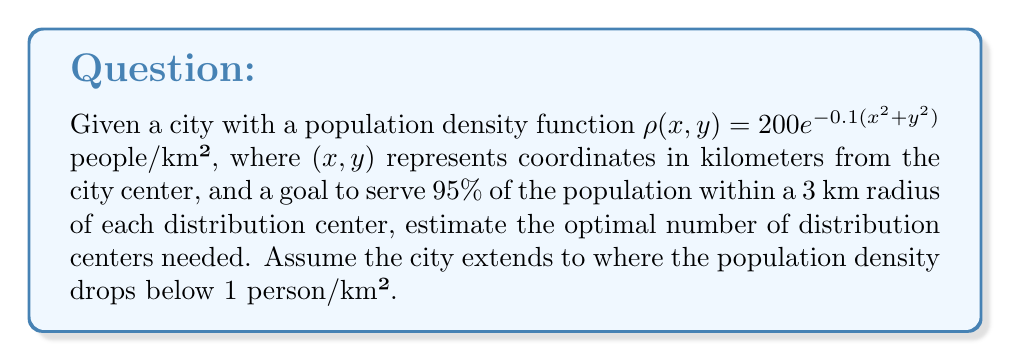Teach me how to tackle this problem. 1. Find the city's boundary:
   Set $\rho(x,y) = 1$ and solve for $r$:
   $$1 = 200e^{-0.1(x^2+y^2)}$$
   $$e^{-0.1(x^2+y^2)} = \frac{1}{200}$$
   $$-0.1(x^2+y^2) = \ln(\frac{1}{200})$$
   $$x^2+y^2 = -10\ln(\frac{1}{200}) \approx 52.6$$
   $$r = \sqrt{52.6} \approx 7.25 \text{ km}$$

2. Calculate the total population:
   $$P = \int_0^{2\pi}\int_0^{7.25} 200e^{-0.1r^2}r\,dr\,d\theta$$
   $$P = 2\pi\int_0^{7.25} 200re^{-0.1r^2}\,dr$$
   $$P = 2\pi[-1000e^{-0.1r^2}]_0^{7.25}$$
   $$P \approx 6283 \text{ people}$$

3. Calculate the population served by one center:
   $$P_c = \int_0^{2\pi}\int_0^3 200e^{-0.1r^2}r\,dr\,d\theta$$
   $$P_c = 2\pi[-1000e^{-0.1r^2}]_0^3$$
   $$P_c \approx 5404 \text{ people}$$

4. Calculate the number of centers needed:
   $$N = \frac{0.95P}{P_c} = \frac{0.95 \times 6283}{5404} \approx 1.1$$

5. Round up to the nearest integer:
   $$N = \lceil 1.1 \rceil = 2$$
Answer: 2 distribution centers 